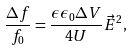Convert formula to latex. <formula><loc_0><loc_0><loc_500><loc_500>\frac { \Delta f } { f _ { 0 } } = \frac { \epsilon \epsilon _ { 0 } \Delta V } { 4 U } \vec { E } ^ { 2 } ,</formula> 